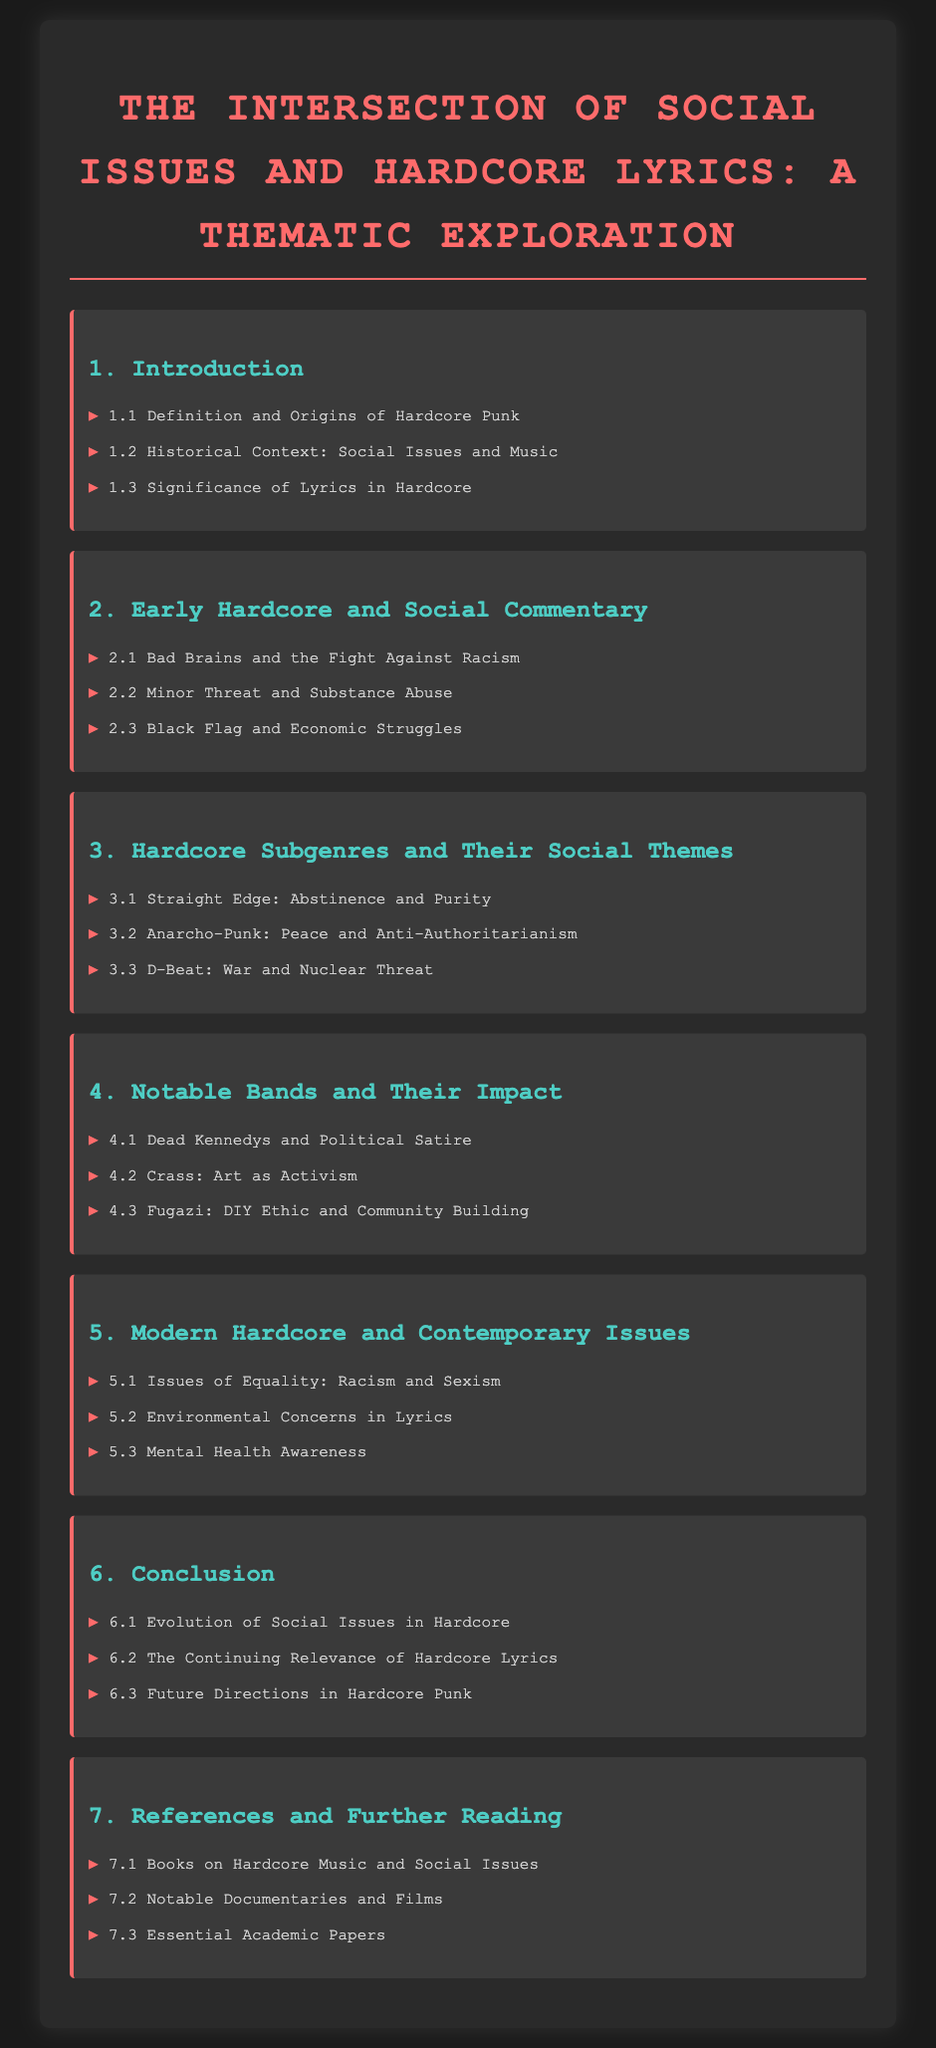what is the title of the document? The title is explicitly stated at the top of the document, which is The Intersection of Social Issues and Hardcore Lyrics: A Thematic Exploration.
Answer: The Intersection of Social Issues and Hardcore Lyrics: A Thematic Exploration how many chapters are included in the Table of Contents? The number of chapters is indicated by the sections listed, which total seven chapters.
Answer: 7 which band is associated with the fight against racism? This information can be found in the section discussing early hardcore and social commentary, where Bad Brains is mentioned regarding racism.
Answer: Bad Brains what social issue does the Straight Edge subgenre focus on? The thematic focus of the Straight Edge subgenre is highlighted in the chapter on hardcore subgenres, which indicates emphasis on abstinence and purity.
Answer: Abstinence and Purity which notable band is mentioned for its contribution to political satire? The notable band recognized for political satire is listed in the section about impactful bands, identified as Dead Kennedys.
Answer: Dead Kennedys what is a contemporary issue discussed in modern hardcore lyrics? The contemporary issues in modern hardcore are specified in the respective chapter, which includes topics like equality, racism, and sexism.
Answer: Racism and Sexism what does the chapter about references include? This section includes various sources that the document refers to, typically categorized into books, documentaries, and academic papers.
Answer: Books on Hardcore Music and Social Issues which chapter discusses the DIY ethic? The chapter that talks about the DIY ethic is focused on Fugazi, which is mentioned in the notable bands section.
Answer: Notable Bands and Their Impact 